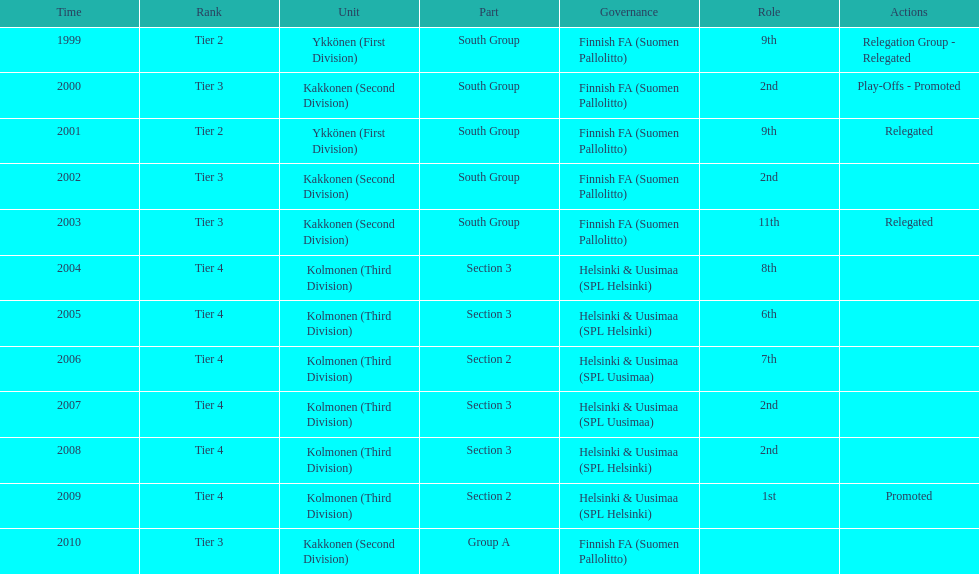How many times has this team been relegated? 3. 